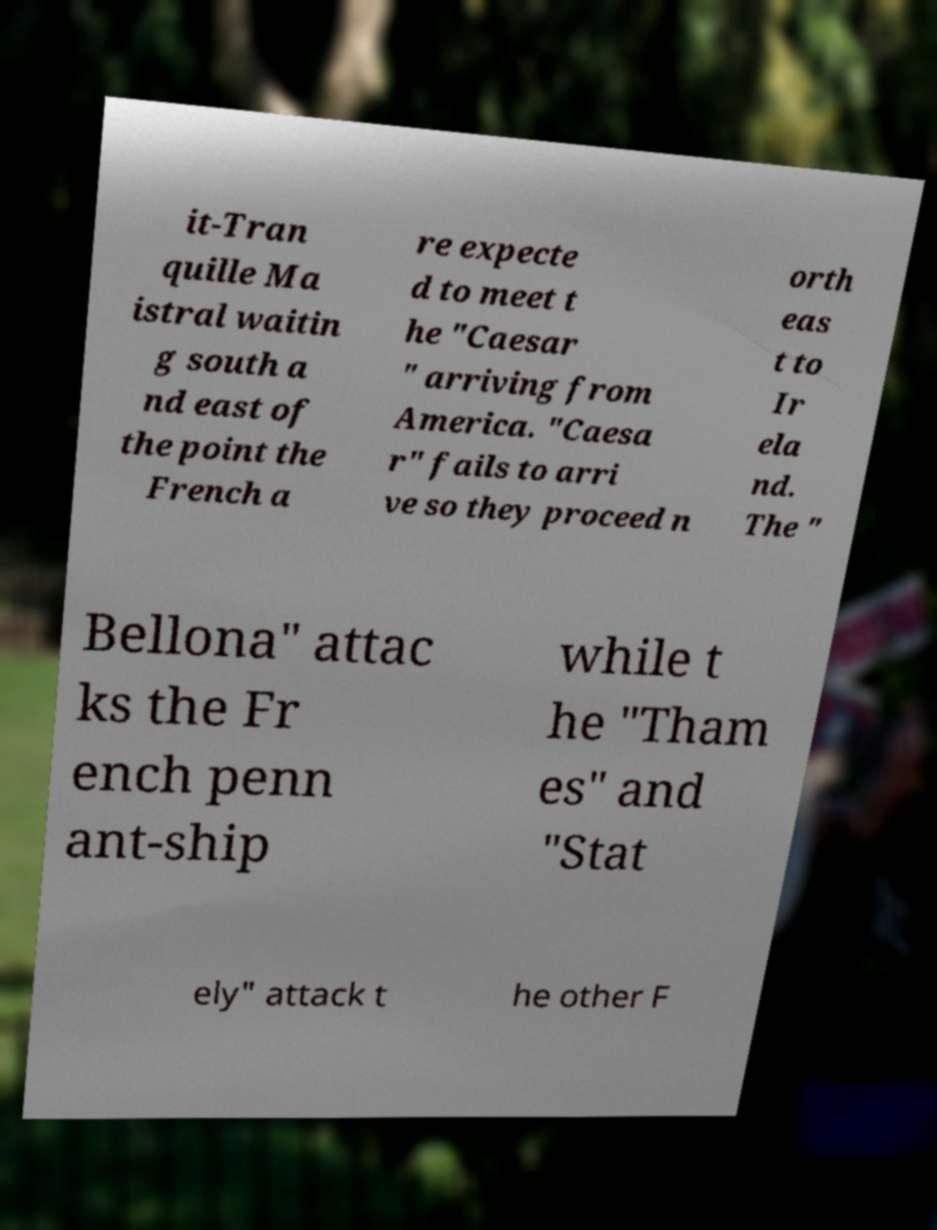Can you read and provide the text displayed in the image?This photo seems to have some interesting text. Can you extract and type it out for me? it-Tran quille Ma istral waitin g south a nd east of the point the French a re expecte d to meet t he "Caesar " arriving from America. "Caesa r" fails to arri ve so they proceed n orth eas t to Ir ela nd. The " Bellona" attac ks the Fr ench penn ant-ship while t he "Tham es" and "Stat ely" attack t he other F 